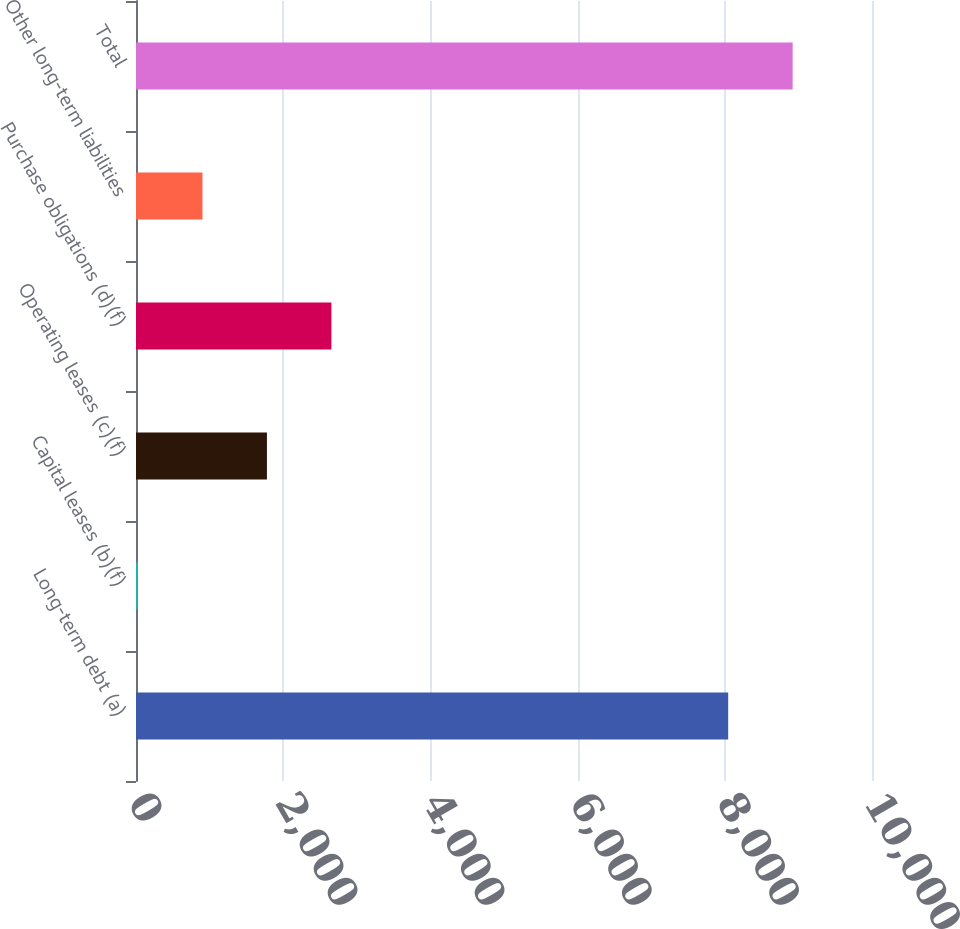Convert chart. <chart><loc_0><loc_0><loc_500><loc_500><bar_chart><fcel>Long-term debt (a)<fcel>Capital leases (b)(f)<fcel>Operating leases (c)(f)<fcel>Purchase obligations (d)(f)<fcel>Other long-term liabilities<fcel>Total<nl><fcel>8046<fcel>27<fcel>1779<fcel>2655<fcel>903<fcel>8922<nl></chart> 